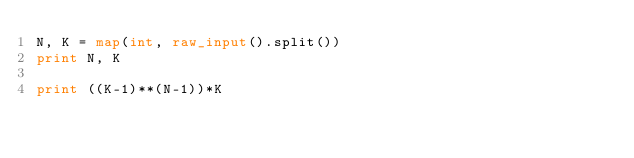Convert code to text. <code><loc_0><loc_0><loc_500><loc_500><_Python_>N, K = map(int, raw_input().split())
print N, K

print ((K-1)**(N-1))*K</code> 